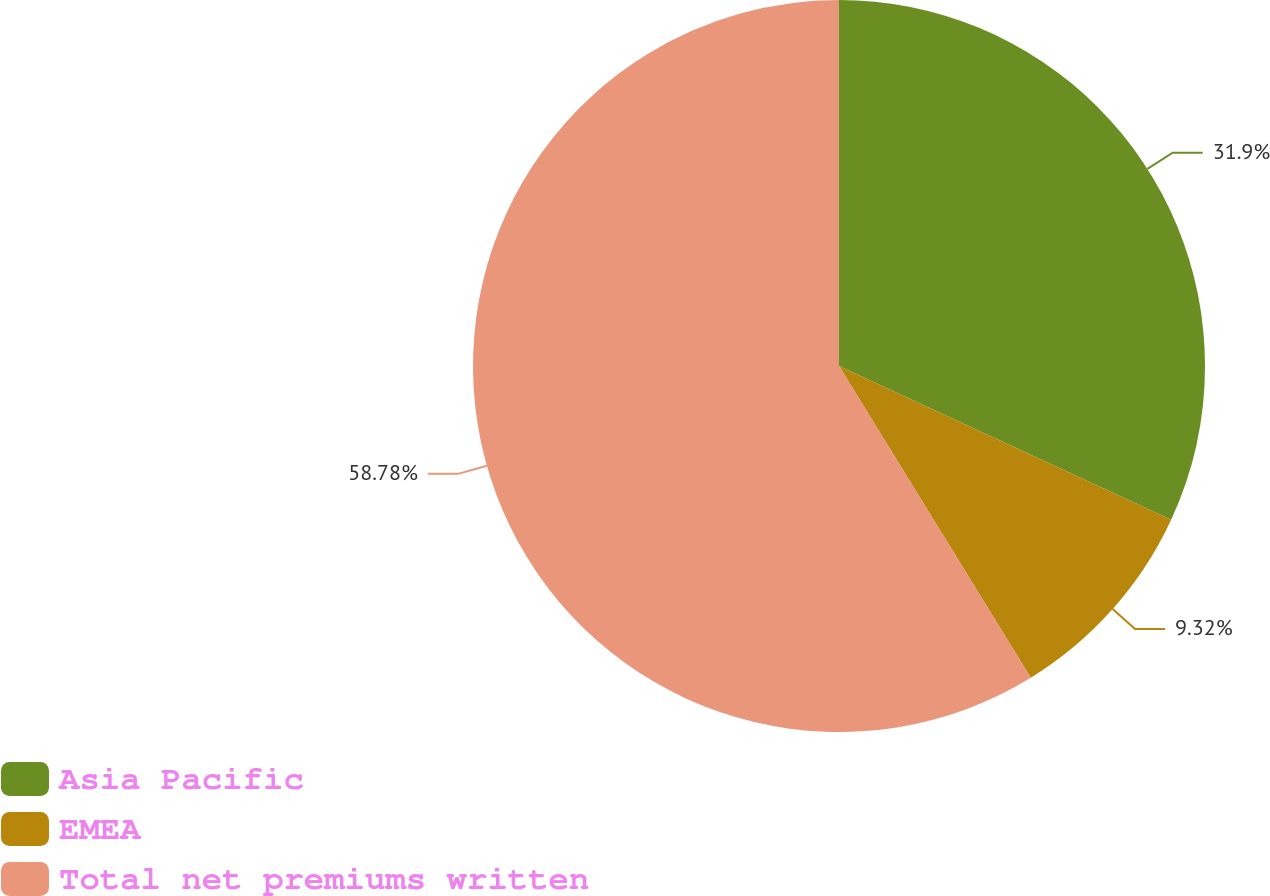Convert chart to OTSL. <chart><loc_0><loc_0><loc_500><loc_500><pie_chart><fcel>Asia Pacific<fcel>EMEA<fcel>Total net premiums written<nl><fcel>31.9%<fcel>9.32%<fcel>58.78%<nl></chart> 